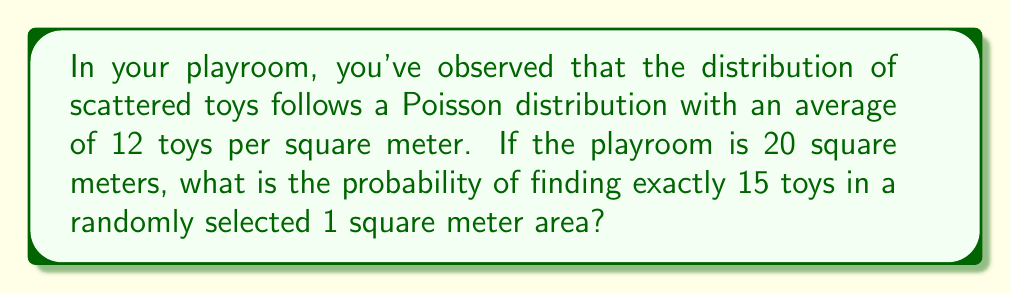What is the answer to this math problem? Let's approach this step-by-step:

1. We are dealing with a Poisson distribution. The probability mass function for a Poisson distribution is:

   $$P(X = k) = \frac{e^{-\lambda} \lambda^k}{k!}$$

   where $\lambda$ is the average number of events in the interval and $k$ is the number of events we're interested in.

2. In this case:
   $\lambda = 12$ (average toys per square meter)
   $k = 15$ (we're looking for exactly 15 toys)

3. Let's substitute these values into the formula:

   $$P(X = 15) = \frac{e^{-12} 12^{15}}{15!}$$

4. Now, let's calculate this step-by-step:
   
   a) First, calculate $12^{15}$:
      $$12^{15} = 1.2288E16$$
   
   b) Calculate $e^{-12}$:
      $$e^{-12} \approx 6.1442E-6$$
   
   c) Calculate $15!$:
      $$15! = 1,307,674,368,000$$

5. Now, let's put it all together:

   $$P(X = 15) = \frac{(6.1442E-6)(1.2288E16)}{1,307,674,368,000} \approx 0.0576$$

6. Convert to a percentage:
   $$0.0576 * 100 = 5.76\%$$
Answer: 5.76% 